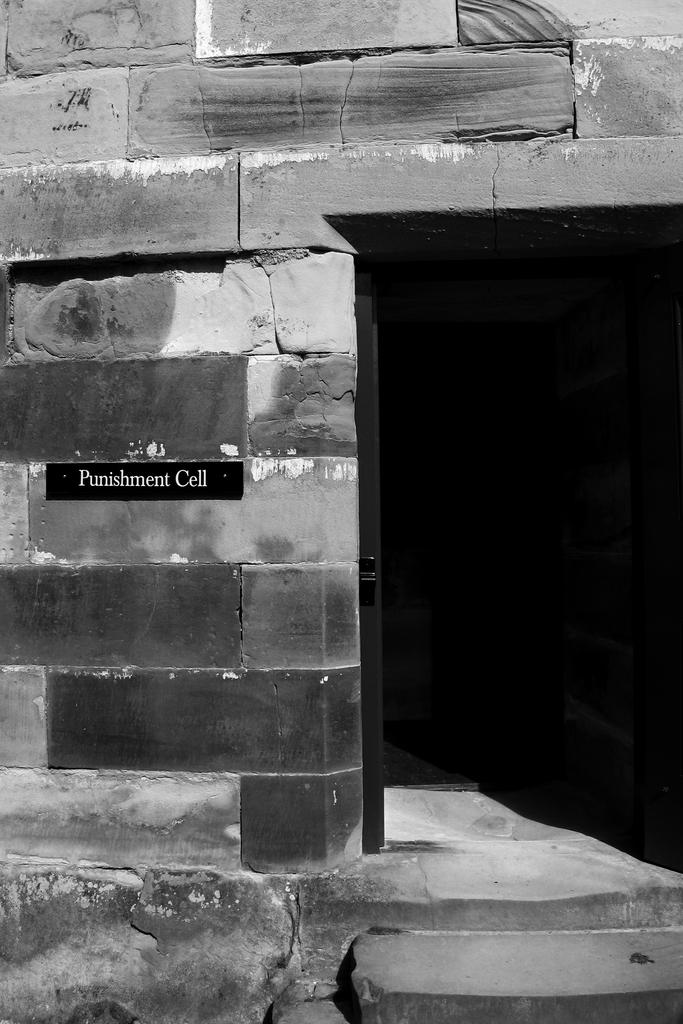What is the color scheme of the image? The image is black and white. What type of structure can be seen in the image? There is a house in the image. What material was used to build the house? The house is built with rocks. What part of the house is visible in the image? The image appears to show an entrance. What object is attached to a wall in the image? There is a board attached to a wall in the image. What type of cord is hanging from the roof in the image? There is no cord hanging from the roof in the image; it is a black and white image of a house built with rocks. 